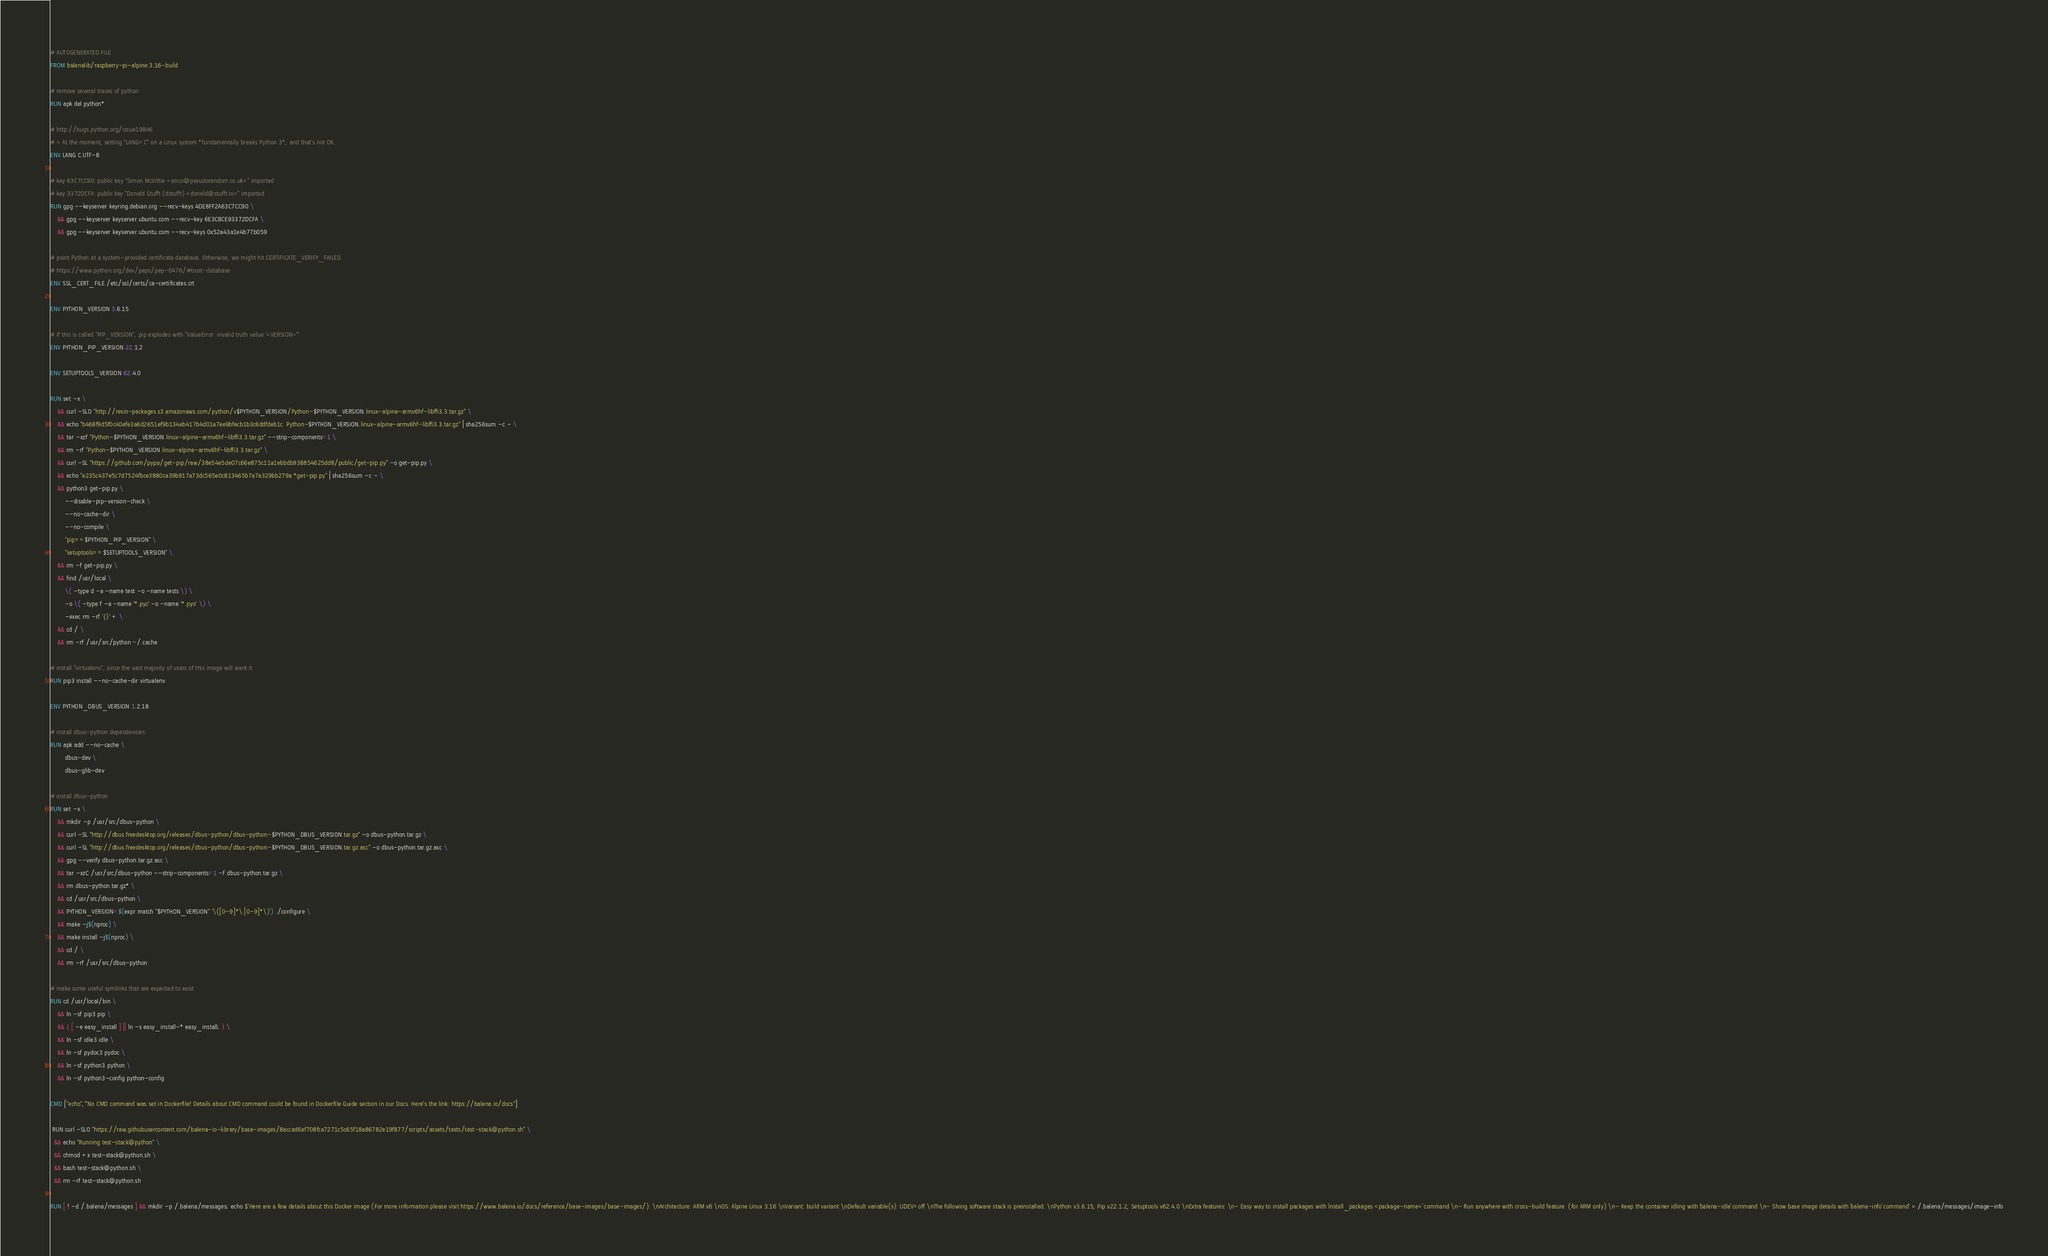<code> <loc_0><loc_0><loc_500><loc_500><_Dockerfile_># AUTOGENERATED FILE
FROM balenalib/raspberry-pi-alpine:3.16-build

# remove several traces of python
RUN apk del python*

# http://bugs.python.org/issue19846
# > At the moment, setting "LANG=C" on a Linux system *fundamentally breaks Python 3*, and that's not OK.
ENV LANG C.UTF-8

# key 63C7CC90: public key "Simon McVittie <smcv@pseudorandom.co.uk>" imported
# key 3372DCFA: public key "Donald Stufft (dstufft) <donald@stufft.io>" imported
RUN gpg --keyserver keyring.debian.org --recv-keys 4DE8FF2A63C7CC90 \
	&& gpg --keyserver keyserver.ubuntu.com --recv-key 6E3CBCE93372DCFA \
	&& gpg --keyserver keyserver.ubuntu.com --recv-keys 0x52a43a1e4b77b059

# point Python at a system-provided certificate database. Otherwise, we might hit CERTIFICATE_VERIFY_FAILED.
# https://www.python.org/dev/peps/pep-0476/#trust-database
ENV SSL_CERT_FILE /etc/ssl/certs/ca-certificates.crt

ENV PYTHON_VERSION 3.6.15

# if this is called "PIP_VERSION", pip explodes with "ValueError: invalid truth value '<VERSION>'"
ENV PYTHON_PIP_VERSION 22.1.2

ENV SETUPTOOLS_VERSION 62.4.0

RUN set -x \
	&& curl -SLO "http://resin-packages.s3.amazonaws.com/python/v$PYTHON_VERSION/Python-$PYTHON_VERSION.linux-alpine-armv6hf-libffi3.3.tar.gz" \
	&& echo "b468f9d5f0c40efe3a6d2651ef9b134eb417b4d01a7ee9bfecb1b3c6ddfdeb1c  Python-$PYTHON_VERSION.linux-alpine-armv6hf-libffi3.3.tar.gz" | sha256sum -c - \
	&& tar -xzf "Python-$PYTHON_VERSION.linux-alpine-armv6hf-libffi3.3.tar.gz" --strip-components=1 \
	&& rm -rf "Python-$PYTHON_VERSION.linux-alpine-armv6hf-libffi3.3.tar.gz" \
	&& curl -SL "https://github.com/pypa/get-pip/raw/38e54e5de07c66e875c11a1ebbdb938854625dd8/public/get-pip.py" -o get-pip.py \
    && echo "e235c437e5c7d7524fbce3880ca39b917a73dc565e0c813465b7a7a329bb279a *get-pip.py" | sha256sum -c - \
    && python3 get-pip.py \
        --disable-pip-version-check \
        --no-cache-dir \
        --no-compile \
        "pip==$PYTHON_PIP_VERSION" \
        "setuptools==$SETUPTOOLS_VERSION" \
	&& rm -f get-pip.py \
	&& find /usr/local \
		\( -type d -a -name test -o -name tests \) \
		-o \( -type f -a -name '*.pyc' -o -name '*.pyo' \) \
		-exec rm -rf '{}' + \
	&& cd / \
	&& rm -rf /usr/src/python ~/.cache

# install "virtualenv", since the vast majority of users of this image will want it
RUN pip3 install --no-cache-dir virtualenv

ENV PYTHON_DBUS_VERSION 1.2.18

# install dbus-python dependencies 
RUN apk add --no-cache \
		dbus-dev \
		dbus-glib-dev

# install dbus-python
RUN set -x \
	&& mkdir -p /usr/src/dbus-python \
	&& curl -SL "http://dbus.freedesktop.org/releases/dbus-python/dbus-python-$PYTHON_DBUS_VERSION.tar.gz" -o dbus-python.tar.gz \
	&& curl -SL "http://dbus.freedesktop.org/releases/dbus-python/dbus-python-$PYTHON_DBUS_VERSION.tar.gz.asc" -o dbus-python.tar.gz.asc \
	&& gpg --verify dbus-python.tar.gz.asc \
	&& tar -xzC /usr/src/dbus-python --strip-components=1 -f dbus-python.tar.gz \
	&& rm dbus-python.tar.gz* \
	&& cd /usr/src/dbus-python \
	&& PYTHON_VERSION=$(expr match "$PYTHON_VERSION" '\([0-9]*\.[0-9]*\)') ./configure \
	&& make -j$(nproc) \
	&& make install -j$(nproc) \
	&& cd / \
	&& rm -rf /usr/src/dbus-python

# make some useful symlinks that are expected to exist
RUN cd /usr/local/bin \
	&& ln -sf pip3 pip \
	&& { [ -e easy_install ] || ln -s easy_install-* easy_install; } \
	&& ln -sf idle3 idle \
	&& ln -sf pydoc3 pydoc \
	&& ln -sf python3 python \
	&& ln -sf python3-config python-config

CMD ["echo","'No CMD command was set in Dockerfile! Details about CMD command could be found in Dockerfile Guide section in our Docs. Here's the link: https://balena.io/docs"]

 RUN curl -SLO "https://raw.githubusercontent.com/balena-io-library/base-images/8accad6af708fca7271c5c65f18a86782e19f877/scripts/assets/tests/test-stack@python.sh" \
  && echo "Running test-stack@python" \
  && chmod +x test-stack@python.sh \
  && bash test-stack@python.sh \
  && rm -rf test-stack@python.sh 

RUN [ ! -d /.balena/messages ] && mkdir -p /.balena/messages; echo $'Here are a few details about this Docker image (For more information please visit https://www.balena.io/docs/reference/base-images/base-images/): \nArchitecture: ARM v6 \nOS: Alpine Linux 3.16 \nVariant: build variant \nDefault variable(s): UDEV=off \nThe following software stack is preinstalled: \nPython v3.6.15, Pip v22.1.2, Setuptools v62.4.0 \nExtra features: \n- Easy way to install packages with `install_packages <package-name>` command \n- Run anywhere with cross-build feature  (for ARM only) \n- Keep the container idling with `balena-idle` command \n- Show base image details with `balena-info` command' > /.balena/messages/image-info</code> 